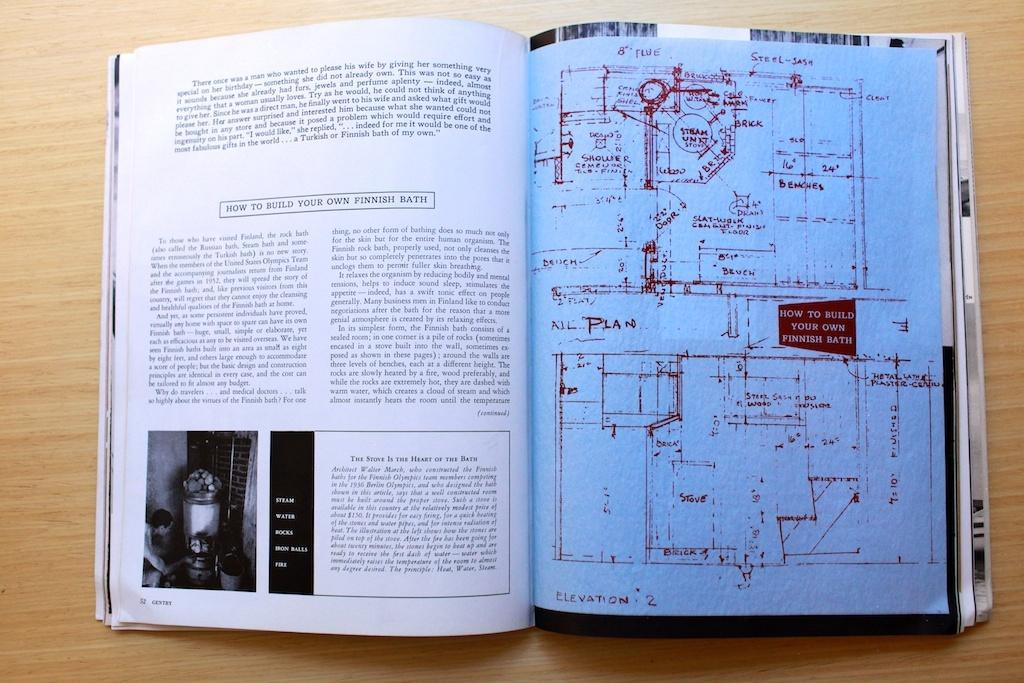Provide a one-sentence caption for the provided image. an open book with instructions on How To Build Your Own Finnish Bath. 